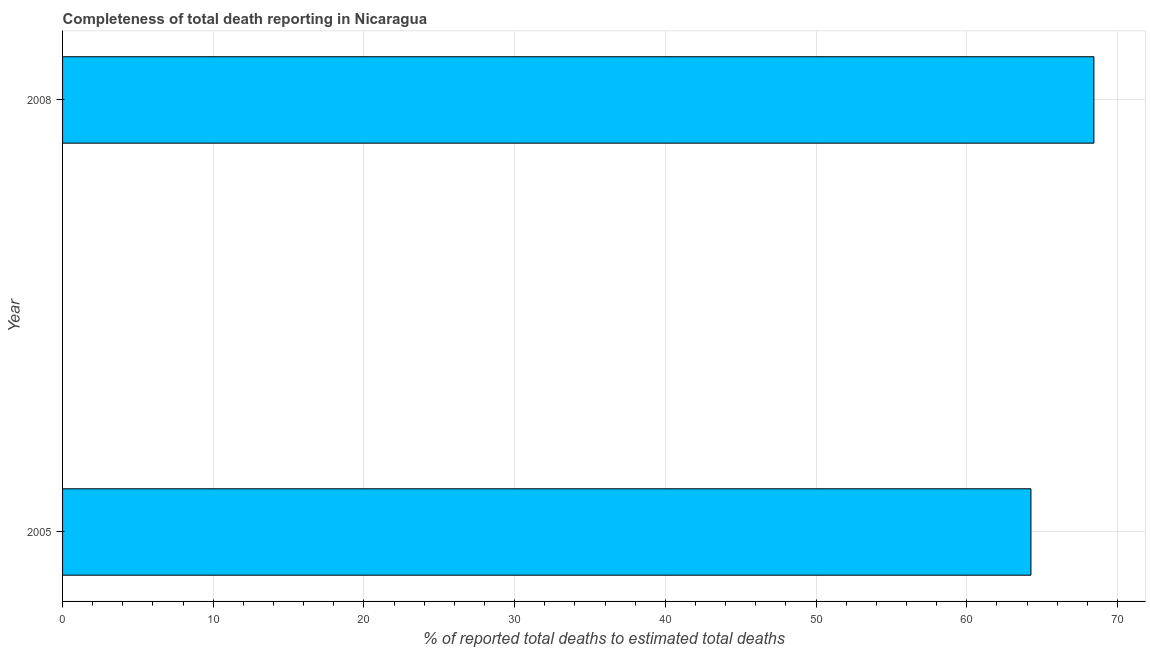Does the graph contain grids?
Offer a terse response. Yes. What is the title of the graph?
Your answer should be compact. Completeness of total death reporting in Nicaragua. What is the label or title of the X-axis?
Your response must be concise. % of reported total deaths to estimated total deaths. What is the completeness of total death reports in 2005?
Keep it short and to the point. 64.26. Across all years, what is the maximum completeness of total death reports?
Give a very brief answer. 68.44. Across all years, what is the minimum completeness of total death reports?
Give a very brief answer. 64.26. In which year was the completeness of total death reports maximum?
Provide a succinct answer. 2008. What is the sum of the completeness of total death reports?
Your answer should be compact. 132.69. What is the difference between the completeness of total death reports in 2005 and 2008?
Provide a short and direct response. -4.18. What is the average completeness of total death reports per year?
Your answer should be compact. 66.35. What is the median completeness of total death reports?
Keep it short and to the point. 66.35. In how many years, is the completeness of total death reports greater than 26 %?
Your answer should be compact. 2. What is the ratio of the completeness of total death reports in 2005 to that in 2008?
Make the answer very short. 0.94. Is the completeness of total death reports in 2005 less than that in 2008?
Ensure brevity in your answer.  Yes. How many bars are there?
Provide a succinct answer. 2. Are all the bars in the graph horizontal?
Provide a short and direct response. Yes. What is the % of reported total deaths to estimated total deaths of 2005?
Your answer should be very brief. 64.26. What is the % of reported total deaths to estimated total deaths in 2008?
Ensure brevity in your answer.  68.44. What is the difference between the % of reported total deaths to estimated total deaths in 2005 and 2008?
Your answer should be compact. -4.18. What is the ratio of the % of reported total deaths to estimated total deaths in 2005 to that in 2008?
Provide a succinct answer. 0.94. 